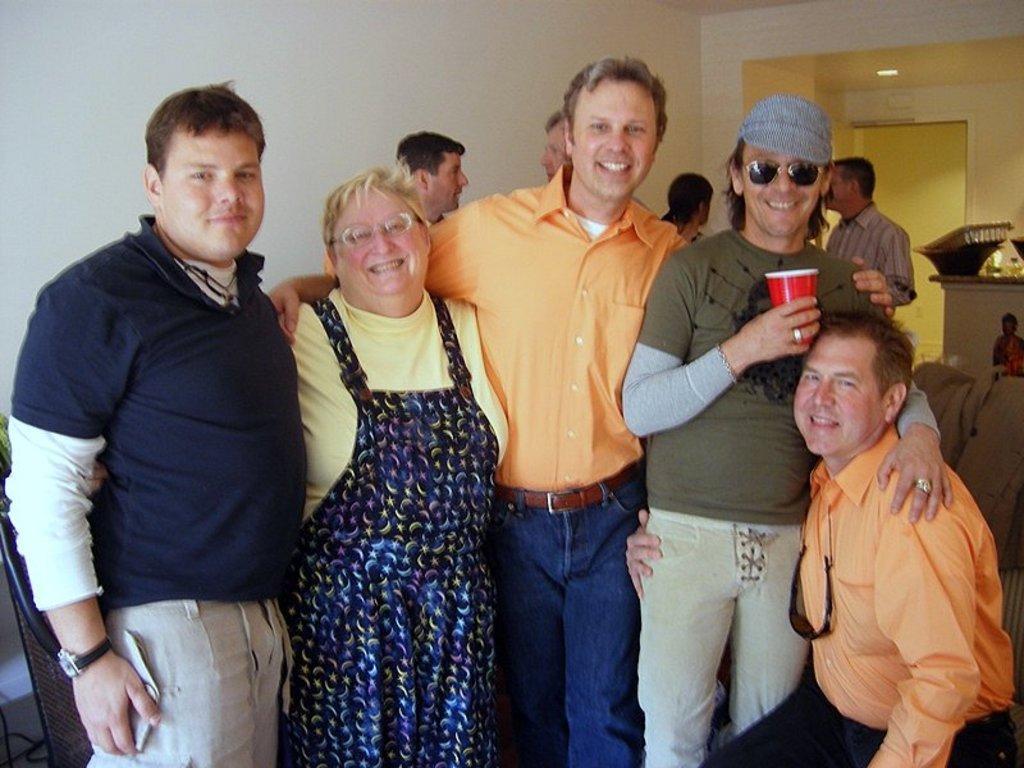In one or two sentences, can you explain what this image depicts? In this image we can see people standing. In the background of the image there is wall. There is a door. 